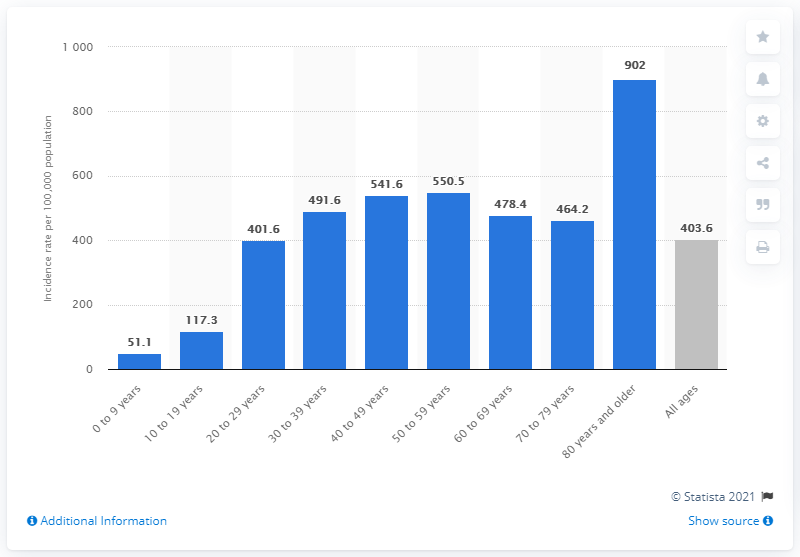Outline some significant characteristics in this image. The highest incidence rate of COVID-19 in the United States was among individuals aged 80 years and older. 